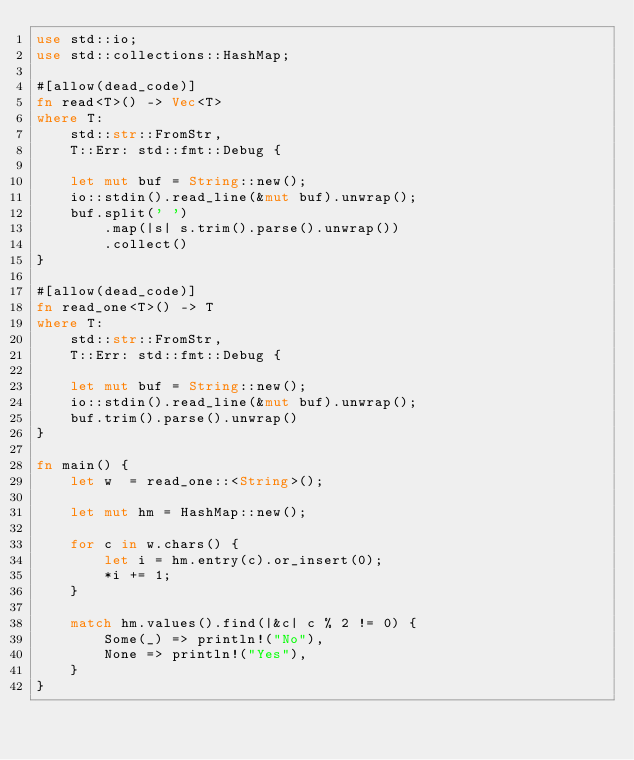Convert code to text. <code><loc_0><loc_0><loc_500><loc_500><_Rust_>use std::io;
use std::collections::HashMap;

#[allow(dead_code)]
fn read<T>() -> Vec<T>
where T:
    std::str::FromStr,
    T::Err: std::fmt::Debug {

    let mut buf = String::new();
    io::stdin().read_line(&mut buf).unwrap();
    buf.split(' ')
        .map(|s| s.trim().parse().unwrap())
        .collect()
}

#[allow(dead_code)]
fn read_one<T>() -> T
where T:
    std::str::FromStr,
    T::Err: std::fmt::Debug {

    let mut buf = String::new();
    io::stdin().read_line(&mut buf).unwrap();
    buf.trim().parse().unwrap()
}

fn main() {
    let w  = read_one::<String>();

    let mut hm = HashMap::new();

    for c in w.chars() {
        let i = hm.entry(c).or_insert(0);
        *i += 1;
    }

    match hm.values().find(|&c| c % 2 != 0) {
        Some(_) => println!("No"),
        None => println!("Yes"),
    }
}</code> 